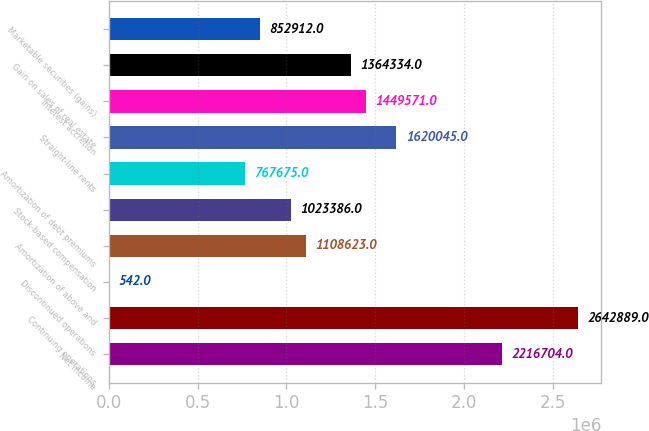<chart> <loc_0><loc_0><loc_500><loc_500><bar_chart><fcel>Net income<fcel>Continuing operations<fcel>Discontinued operations<fcel>Amortization of above and<fcel>Stock-based compensation<fcel>Amortization of debt premiums<fcel>Straight-line rents<fcel>Interest accretion<fcel>Gain on sales of real estate<fcel>Marketable securities (gains)<nl><fcel>2.2167e+06<fcel>2.64289e+06<fcel>542<fcel>1.10862e+06<fcel>1.02339e+06<fcel>767675<fcel>1.62004e+06<fcel>1.44957e+06<fcel>1.36433e+06<fcel>852912<nl></chart> 